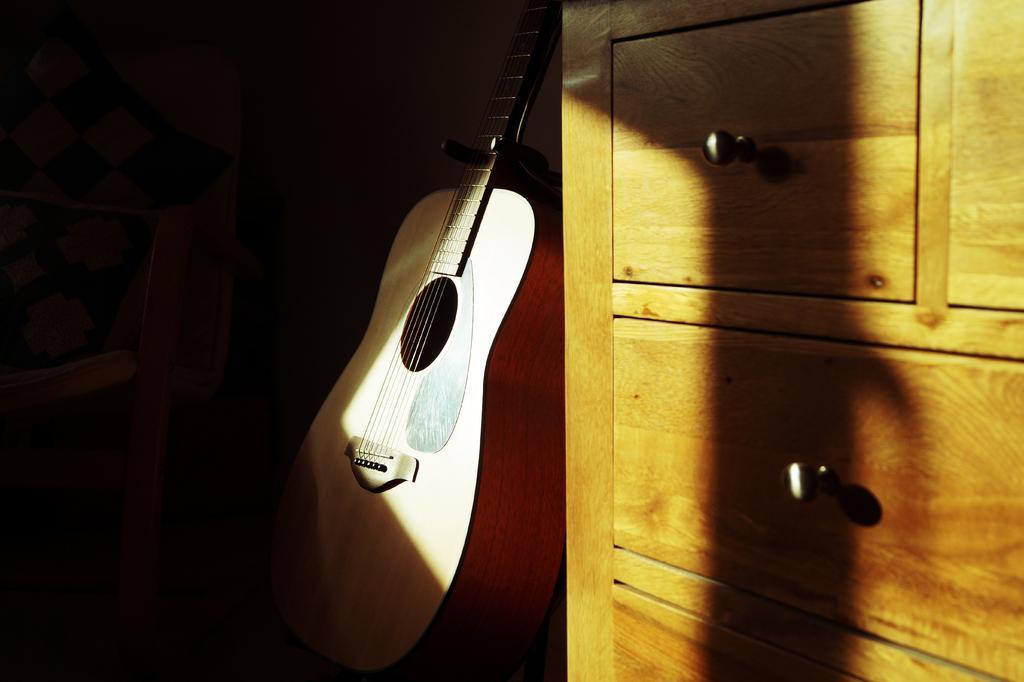In one or two sentences, can you explain what this image depicts? In the middle of the image there is a guitar. Right side of the image there is a cupboard. Left side of the image there is chair. 